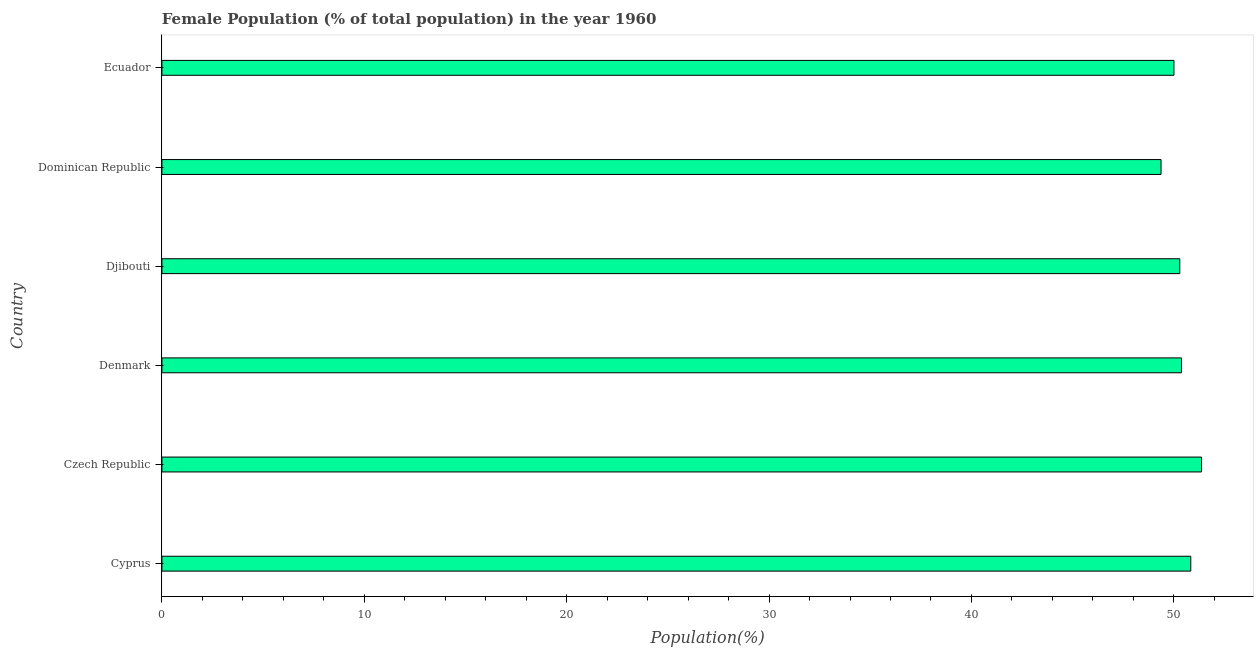What is the title of the graph?
Give a very brief answer. Female Population (% of total population) in the year 1960. What is the label or title of the X-axis?
Make the answer very short. Population(%). What is the female population in Cyprus?
Keep it short and to the point. 50.84. Across all countries, what is the maximum female population?
Provide a succinct answer. 51.37. Across all countries, what is the minimum female population?
Provide a short and direct response. 49.37. In which country was the female population maximum?
Make the answer very short. Czech Republic. In which country was the female population minimum?
Offer a very short reply. Dominican Republic. What is the sum of the female population?
Your answer should be very brief. 302.25. What is the average female population per country?
Offer a very short reply. 50.38. What is the median female population?
Keep it short and to the point. 50.34. In how many countries, is the female population greater than 36 %?
Ensure brevity in your answer.  6. What is the difference between the highest and the second highest female population?
Offer a terse response. 0.53. Is the sum of the female population in Denmark and Ecuador greater than the maximum female population across all countries?
Your answer should be very brief. Yes. What is the difference between the highest and the lowest female population?
Provide a short and direct response. 2. In how many countries, is the female population greater than the average female population taken over all countries?
Offer a very short reply. 3. How many bars are there?
Your response must be concise. 6. Are all the bars in the graph horizontal?
Provide a succinct answer. Yes. How many countries are there in the graph?
Your response must be concise. 6. What is the Population(%) in Cyprus?
Provide a succinct answer. 50.84. What is the Population(%) of Czech Republic?
Ensure brevity in your answer.  51.37. What is the Population(%) of Denmark?
Make the answer very short. 50.38. What is the Population(%) in Djibouti?
Your response must be concise. 50.29. What is the Population(%) of Dominican Republic?
Ensure brevity in your answer.  49.37. What is the Population(%) of Ecuador?
Make the answer very short. 50.01. What is the difference between the Population(%) in Cyprus and Czech Republic?
Offer a very short reply. -0.53. What is the difference between the Population(%) in Cyprus and Denmark?
Ensure brevity in your answer.  0.46. What is the difference between the Population(%) in Cyprus and Djibouti?
Offer a very short reply. 0.54. What is the difference between the Population(%) in Cyprus and Dominican Republic?
Ensure brevity in your answer.  1.47. What is the difference between the Population(%) in Cyprus and Ecuador?
Your response must be concise. 0.83. What is the difference between the Population(%) in Czech Republic and Denmark?
Provide a succinct answer. 0.99. What is the difference between the Population(%) in Czech Republic and Djibouti?
Your answer should be compact. 1.07. What is the difference between the Population(%) in Czech Republic and Dominican Republic?
Offer a very short reply. 2. What is the difference between the Population(%) in Czech Republic and Ecuador?
Your response must be concise. 1.36. What is the difference between the Population(%) in Denmark and Djibouti?
Your answer should be compact. 0.08. What is the difference between the Population(%) in Denmark and Dominican Republic?
Your answer should be very brief. 1.01. What is the difference between the Population(%) in Denmark and Ecuador?
Give a very brief answer. 0.37. What is the difference between the Population(%) in Djibouti and Dominican Republic?
Ensure brevity in your answer.  0.93. What is the difference between the Population(%) in Djibouti and Ecuador?
Keep it short and to the point. 0.29. What is the difference between the Population(%) in Dominican Republic and Ecuador?
Offer a terse response. -0.64. What is the ratio of the Population(%) in Cyprus to that in Denmark?
Your response must be concise. 1.01. What is the ratio of the Population(%) in Cyprus to that in Dominican Republic?
Offer a terse response. 1.03. What is the ratio of the Population(%) in Czech Republic to that in Dominican Republic?
Ensure brevity in your answer.  1.04. What is the ratio of the Population(%) in Czech Republic to that in Ecuador?
Offer a terse response. 1.03. What is the ratio of the Population(%) in Denmark to that in Djibouti?
Give a very brief answer. 1. What is the ratio of the Population(%) in Denmark to that in Dominican Republic?
Your answer should be compact. 1.02. What is the ratio of the Population(%) in Denmark to that in Ecuador?
Keep it short and to the point. 1.01. What is the ratio of the Population(%) in Djibouti to that in Dominican Republic?
Provide a short and direct response. 1.02. What is the ratio of the Population(%) in Djibouti to that in Ecuador?
Ensure brevity in your answer.  1.01. 